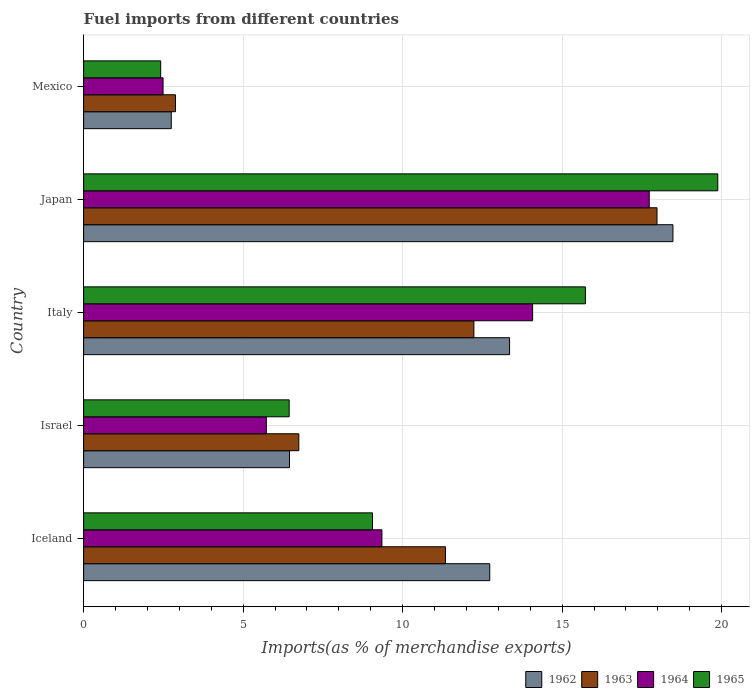How many different coloured bars are there?
Ensure brevity in your answer.  4. How many groups of bars are there?
Keep it short and to the point. 5. Are the number of bars per tick equal to the number of legend labels?
Ensure brevity in your answer.  Yes. What is the label of the 2nd group of bars from the top?
Offer a very short reply. Japan. What is the percentage of imports to different countries in 1962 in Iceland?
Your response must be concise. 12.73. Across all countries, what is the maximum percentage of imports to different countries in 1965?
Offer a terse response. 19.88. Across all countries, what is the minimum percentage of imports to different countries in 1964?
Ensure brevity in your answer.  2.49. What is the total percentage of imports to different countries in 1963 in the graph?
Provide a succinct answer. 51.18. What is the difference between the percentage of imports to different countries in 1962 in Japan and that in Mexico?
Provide a short and direct response. 15.73. What is the difference between the percentage of imports to different countries in 1964 in Japan and the percentage of imports to different countries in 1965 in Mexico?
Make the answer very short. 15.32. What is the average percentage of imports to different countries in 1962 per country?
Ensure brevity in your answer.  10.75. What is the difference between the percentage of imports to different countries in 1964 and percentage of imports to different countries in 1965 in Japan?
Your answer should be compact. -2.15. What is the ratio of the percentage of imports to different countries in 1965 in Italy to that in Mexico?
Give a very brief answer. 6.51. Is the percentage of imports to different countries in 1963 in Israel less than that in Italy?
Make the answer very short. Yes. Is the difference between the percentage of imports to different countries in 1964 in Iceland and Israel greater than the difference between the percentage of imports to different countries in 1965 in Iceland and Israel?
Offer a very short reply. Yes. What is the difference between the highest and the second highest percentage of imports to different countries in 1963?
Make the answer very short. 5.74. What is the difference between the highest and the lowest percentage of imports to different countries in 1962?
Offer a terse response. 15.73. In how many countries, is the percentage of imports to different countries in 1963 greater than the average percentage of imports to different countries in 1963 taken over all countries?
Your response must be concise. 3. Is the sum of the percentage of imports to different countries in 1962 in Israel and Japan greater than the maximum percentage of imports to different countries in 1963 across all countries?
Your response must be concise. Yes. Is it the case that in every country, the sum of the percentage of imports to different countries in 1963 and percentage of imports to different countries in 1964 is greater than the sum of percentage of imports to different countries in 1962 and percentage of imports to different countries in 1965?
Make the answer very short. No. What does the 3rd bar from the bottom in Iceland represents?
Ensure brevity in your answer.  1964. Is it the case that in every country, the sum of the percentage of imports to different countries in 1963 and percentage of imports to different countries in 1965 is greater than the percentage of imports to different countries in 1964?
Your response must be concise. Yes. How many bars are there?
Provide a short and direct response. 20. How many countries are there in the graph?
Offer a terse response. 5. Does the graph contain grids?
Offer a terse response. Yes. Where does the legend appear in the graph?
Give a very brief answer. Bottom right. What is the title of the graph?
Offer a terse response. Fuel imports from different countries. Does "1987" appear as one of the legend labels in the graph?
Provide a succinct answer. No. What is the label or title of the X-axis?
Offer a very short reply. Imports(as % of merchandise exports). What is the label or title of the Y-axis?
Your answer should be compact. Country. What is the Imports(as % of merchandise exports) of 1962 in Iceland?
Make the answer very short. 12.73. What is the Imports(as % of merchandise exports) of 1963 in Iceland?
Make the answer very short. 11.35. What is the Imports(as % of merchandise exports) of 1964 in Iceland?
Offer a terse response. 9.35. What is the Imports(as % of merchandise exports) in 1965 in Iceland?
Your answer should be very brief. 9.06. What is the Imports(as % of merchandise exports) in 1962 in Israel?
Give a very brief answer. 6.45. What is the Imports(as % of merchandise exports) in 1963 in Israel?
Your answer should be very brief. 6.75. What is the Imports(as % of merchandise exports) of 1964 in Israel?
Keep it short and to the point. 5.73. What is the Imports(as % of merchandise exports) of 1965 in Israel?
Offer a very short reply. 6.44. What is the Imports(as % of merchandise exports) in 1962 in Italy?
Give a very brief answer. 13.35. What is the Imports(as % of merchandise exports) in 1963 in Italy?
Your response must be concise. 12.23. What is the Imports(as % of merchandise exports) in 1964 in Italy?
Keep it short and to the point. 14.07. What is the Imports(as % of merchandise exports) of 1965 in Italy?
Your answer should be very brief. 15.73. What is the Imports(as % of merchandise exports) in 1962 in Japan?
Your answer should be very brief. 18.47. What is the Imports(as % of merchandise exports) in 1963 in Japan?
Offer a terse response. 17.97. What is the Imports(as % of merchandise exports) of 1964 in Japan?
Offer a terse response. 17.73. What is the Imports(as % of merchandise exports) in 1965 in Japan?
Make the answer very short. 19.88. What is the Imports(as % of merchandise exports) of 1962 in Mexico?
Keep it short and to the point. 2.75. What is the Imports(as % of merchandise exports) in 1963 in Mexico?
Keep it short and to the point. 2.88. What is the Imports(as % of merchandise exports) of 1964 in Mexico?
Your answer should be compact. 2.49. What is the Imports(as % of merchandise exports) of 1965 in Mexico?
Provide a short and direct response. 2.42. Across all countries, what is the maximum Imports(as % of merchandise exports) of 1962?
Ensure brevity in your answer.  18.47. Across all countries, what is the maximum Imports(as % of merchandise exports) of 1963?
Your answer should be very brief. 17.97. Across all countries, what is the maximum Imports(as % of merchandise exports) of 1964?
Make the answer very short. 17.73. Across all countries, what is the maximum Imports(as % of merchandise exports) in 1965?
Make the answer very short. 19.88. Across all countries, what is the minimum Imports(as % of merchandise exports) of 1962?
Provide a short and direct response. 2.75. Across all countries, what is the minimum Imports(as % of merchandise exports) of 1963?
Your answer should be very brief. 2.88. Across all countries, what is the minimum Imports(as % of merchandise exports) of 1964?
Provide a short and direct response. 2.49. Across all countries, what is the minimum Imports(as % of merchandise exports) in 1965?
Your answer should be very brief. 2.42. What is the total Imports(as % of merchandise exports) of 1962 in the graph?
Your answer should be very brief. 53.76. What is the total Imports(as % of merchandise exports) in 1963 in the graph?
Keep it short and to the point. 51.18. What is the total Imports(as % of merchandise exports) of 1964 in the graph?
Offer a terse response. 49.38. What is the total Imports(as % of merchandise exports) in 1965 in the graph?
Offer a very short reply. 53.53. What is the difference between the Imports(as % of merchandise exports) in 1962 in Iceland and that in Israel?
Offer a very short reply. 6.28. What is the difference between the Imports(as % of merchandise exports) in 1963 in Iceland and that in Israel?
Your response must be concise. 4.6. What is the difference between the Imports(as % of merchandise exports) of 1964 in Iceland and that in Israel?
Offer a very short reply. 3.62. What is the difference between the Imports(as % of merchandise exports) of 1965 in Iceland and that in Israel?
Your response must be concise. 2.61. What is the difference between the Imports(as % of merchandise exports) of 1962 in Iceland and that in Italy?
Ensure brevity in your answer.  -0.62. What is the difference between the Imports(as % of merchandise exports) of 1963 in Iceland and that in Italy?
Offer a terse response. -0.89. What is the difference between the Imports(as % of merchandise exports) in 1964 in Iceland and that in Italy?
Offer a terse response. -4.72. What is the difference between the Imports(as % of merchandise exports) in 1965 in Iceland and that in Italy?
Provide a succinct answer. -6.67. What is the difference between the Imports(as % of merchandise exports) of 1962 in Iceland and that in Japan?
Your response must be concise. -5.74. What is the difference between the Imports(as % of merchandise exports) in 1963 in Iceland and that in Japan?
Keep it short and to the point. -6.63. What is the difference between the Imports(as % of merchandise exports) in 1964 in Iceland and that in Japan?
Offer a very short reply. -8.38. What is the difference between the Imports(as % of merchandise exports) of 1965 in Iceland and that in Japan?
Offer a very short reply. -10.82. What is the difference between the Imports(as % of merchandise exports) of 1962 in Iceland and that in Mexico?
Provide a succinct answer. 9.98. What is the difference between the Imports(as % of merchandise exports) in 1963 in Iceland and that in Mexico?
Provide a succinct answer. 8.47. What is the difference between the Imports(as % of merchandise exports) of 1964 in Iceland and that in Mexico?
Give a very brief answer. 6.86. What is the difference between the Imports(as % of merchandise exports) in 1965 in Iceland and that in Mexico?
Offer a terse response. 6.64. What is the difference between the Imports(as % of merchandise exports) of 1962 in Israel and that in Italy?
Your answer should be very brief. -6.9. What is the difference between the Imports(as % of merchandise exports) of 1963 in Israel and that in Italy?
Offer a terse response. -5.49. What is the difference between the Imports(as % of merchandise exports) of 1964 in Israel and that in Italy?
Provide a short and direct response. -8.35. What is the difference between the Imports(as % of merchandise exports) of 1965 in Israel and that in Italy?
Your response must be concise. -9.29. What is the difference between the Imports(as % of merchandise exports) in 1962 in Israel and that in Japan?
Keep it short and to the point. -12.02. What is the difference between the Imports(as % of merchandise exports) of 1963 in Israel and that in Japan?
Ensure brevity in your answer.  -11.23. What is the difference between the Imports(as % of merchandise exports) of 1964 in Israel and that in Japan?
Offer a terse response. -12. What is the difference between the Imports(as % of merchandise exports) of 1965 in Israel and that in Japan?
Give a very brief answer. -13.44. What is the difference between the Imports(as % of merchandise exports) of 1962 in Israel and that in Mexico?
Make the answer very short. 3.71. What is the difference between the Imports(as % of merchandise exports) in 1963 in Israel and that in Mexico?
Your response must be concise. 3.87. What is the difference between the Imports(as % of merchandise exports) in 1964 in Israel and that in Mexico?
Provide a short and direct response. 3.24. What is the difference between the Imports(as % of merchandise exports) of 1965 in Israel and that in Mexico?
Keep it short and to the point. 4.03. What is the difference between the Imports(as % of merchandise exports) of 1962 in Italy and that in Japan?
Your answer should be very brief. -5.12. What is the difference between the Imports(as % of merchandise exports) of 1963 in Italy and that in Japan?
Provide a succinct answer. -5.74. What is the difference between the Imports(as % of merchandise exports) of 1964 in Italy and that in Japan?
Make the answer very short. -3.66. What is the difference between the Imports(as % of merchandise exports) in 1965 in Italy and that in Japan?
Keep it short and to the point. -4.15. What is the difference between the Imports(as % of merchandise exports) in 1962 in Italy and that in Mexico?
Give a very brief answer. 10.61. What is the difference between the Imports(as % of merchandise exports) of 1963 in Italy and that in Mexico?
Make the answer very short. 9.36. What is the difference between the Imports(as % of merchandise exports) in 1964 in Italy and that in Mexico?
Ensure brevity in your answer.  11.58. What is the difference between the Imports(as % of merchandise exports) of 1965 in Italy and that in Mexico?
Keep it short and to the point. 13.31. What is the difference between the Imports(as % of merchandise exports) of 1962 in Japan and that in Mexico?
Your answer should be compact. 15.73. What is the difference between the Imports(as % of merchandise exports) of 1963 in Japan and that in Mexico?
Offer a terse response. 15.1. What is the difference between the Imports(as % of merchandise exports) in 1964 in Japan and that in Mexico?
Offer a terse response. 15.24. What is the difference between the Imports(as % of merchandise exports) of 1965 in Japan and that in Mexico?
Offer a terse response. 17.46. What is the difference between the Imports(as % of merchandise exports) in 1962 in Iceland and the Imports(as % of merchandise exports) in 1963 in Israel?
Provide a short and direct response. 5.99. What is the difference between the Imports(as % of merchandise exports) of 1962 in Iceland and the Imports(as % of merchandise exports) of 1964 in Israel?
Ensure brevity in your answer.  7. What is the difference between the Imports(as % of merchandise exports) of 1962 in Iceland and the Imports(as % of merchandise exports) of 1965 in Israel?
Offer a very short reply. 6.29. What is the difference between the Imports(as % of merchandise exports) of 1963 in Iceland and the Imports(as % of merchandise exports) of 1964 in Israel?
Keep it short and to the point. 5.62. What is the difference between the Imports(as % of merchandise exports) of 1963 in Iceland and the Imports(as % of merchandise exports) of 1965 in Israel?
Offer a terse response. 4.9. What is the difference between the Imports(as % of merchandise exports) of 1964 in Iceland and the Imports(as % of merchandise exports) of 1965 in Israel?
Give a very brief answer. 2.91. What is the difference between the Imports(as % of merchandise exports) of 1962 in Iceland and the Imports(as % of merchandise exports) of 1963 in Italy?
Your answer should be very brief. 0.5. What is the difference between the Imports(as % of merchandise exports) of 1962 in Iceland and the Imports(as % of merchandise exports) of 1964 in Italy?
Provide a succinct answer. -1.34. What is the difference between the Imports(as % of merchandise exports) of 1962 in Iceland and the Imports(as % of merchandise exports) of 1965 in Italy?
Your answer should be compact. -3. What is the difference between the Imports(as % of merchandise exports) in 1963 in Iceland and the Imports(as % of merchandise exports) in 1964 in Italy?
Offer a very short reply. -2.73. What is the difference between the Imports(as % of merchandise exports) in 1963 in Iceland and the Imports(as % of merchandise exports) in 1965 in Italy?
Offer a very short reply. -4.38. What is the difference between the Imports(as % of merchandise exports) in 1964 in Iceland and the Imports(as % of merchandise exports) in 1965 in Italy?
Offer a terse response. -6.38. What is the difference between the Imports(as % of merchandise exports) in 1962 in Iceland and the Imports(as % of merchandise exports) in 1963 in Japan?
Provide a short and direct response. -5.24. What is the difference between the Imports(as % of merchandise exports) in 1962 in Iceland and the Imports(as % of merchandise exports) in 1964 in Japan?
Offer a very short reply. -5. What is the difference between the Imports(as % of merchandise exports) of 1962 in Iceland and the Imports(as % of merchandise exports) of 1965 in Japan?
Your response must be concise. -7.15. What is the difference between the Imports(as % of merchandise exports) in 1963 in Iceland and the Imports(as % of merchandise exports) in 1964 in Japan?
Keep it short and to the point. -6.39. What is the difference between the Imports(as % of merchandise exports) of 1963 in Iceland and the Imports(as % of merchandise exports) of 1965 in Japan?
Your answer should be compact. -8.53. What is the difference between the Imports(as % of merchandise exports) of 1964 in Iceland and the Imports(as % of merchandise exports) of 1965 in Japan?
Offer a terse response. -10.53. What is the difference between the Imports(as % of merchandise exports) in 1962 in Iceland and the Imports(as % of merchandise exports) in 1963 in Mexico?
Keep it short and to the point. 9.85. What is the difference between the Imports(as % of merchandise exports) of 1962 in Iceland and the Imports(as % of merchandise exports) of 1964 in Mexico?
Keep it short and to the point. 10.24. What is the difference between the Imports(as % of merchandise exports) of 1962 in Iceland and the Imports(as % of merchandise exports) of 1965 in Mexico?
Ensure brevity in your answer.  10.32. What is the difference between the Imports(as % of merchandise exports) of 1963 in Iceland and the Imports(as % of merchandise exports) of 1964 in Mexico?
Keep it short and to the point. 8.85. What is the difference between the Imports(as % of merchandise exports) of 1963 in Iceland and the Imports(as % of merchandise exports) of 1965 in Mexico?
Offer a very short reply. 8.93. What is the difference between the Imports(as % of merchandise exports) in 1964 in Iceland and the Imports(as % of merchandise exports) in 1965 in Mexico?
Ensure brevity in your answer.  6.94. What is the difference between the Imports(as % of merchandise exports) in 1962 in Israel and the Imports(as % of merchandise exports) in 1963 in Italy?
Make the answer very short. -5.78. What is the difference between the Imports(as % of merchandise exports) in 1962 in Israel and the Imports(as % of merchandise exports) in 1964 in Italy?
Give a very brief answer. -7.62. What is the difference between the Imports(as % of merchandise exports) in 1962 in Israel and the Imports(as % of merchandise exports) in 1965 in Italy?
Keep it short and to the point. -9.28. What is the difference between the Imports(as % of merchandise exports) of 1963 in Israel and the Imports(as % of merchandise exports) of 1964 in Italy?
Your response must be concise. -7.33. What is the difference between the Imports(as % of merchandise exports) of 1963 in Israel and the Imports(as % of merchandise exports) of 1965 in Italy?
Provide a succinct answer. -8.98. What is the difference between the Imports(as % of merchandise exports) of 1964 in Israel and the Imports(as % of merchandise exports) of 1965 in Italy?
Make the answer very short. -10. What is the difference between the Imports(as % of merchandise exports) in 1962 in Israel and the Imports(as % of merchandise exports) in 1963 in Japan?
Offer a terse response. -11.52. What is the difference between the Imports(as % of merchandise exports) in 1962 in Israel and the Imports(as % of merchandise exports) in 1964 in Japan?
Provide a succinct answer. -11.28. What is the difference between the Imports(as % of merchandise exports) of 1962 in Israel and the Imports(as % of merchandise exports) of 1965 in Japan?
Ensure brevity in your answer.  -13.43. What is the difference between the Imports(as % of merchandise exports) of 1963 in Israel and the Imports(as % of merchandise exports) of 1964 in Japan?
Give a very brief answer. -10.99. What is the difference between the Imports(as % of merchandise exports) of 1963 in Israel and the Imports(as % of merchandise exports) of 1965 in Japan?
Provide a short and direct response. -13.13. What is the difference between the Imports(as % of merchandise exports) of 1964 in Israel and the Imports(as % of merchandise exports) of 1965 in Japan?
Offer a terse response. -14.15. What is the difference between the Imports(as % of merchandise exports) in 1962 in Israel and the Imports(as % of merchandise exports) in 1963 in Mexico?
Your answer should be compact. 3.58. What is the difference between the Imports(as % of merchandise exports) in 1962 in Israel and the Imports(as % of merchandise exports) in 1964 in Mexico?
Make the answer very short. 3.96. What is the difference between the Imports(as % of merchandise exports) in 1962 in Israel and the Imports(as % of merchandise exports) in 1965 in Mexico?
Offer a terse response. 4.04. What is the difference between the Imports(as % of merchandise exports) of 1963 in Israel and the Imports(as % of merchandise exports) of 1964 in Mexico?
Ensure brevity in your answer.  4.26. What is the difference between the Imports(as % of merchandise exports) of 1963 in Israel and the Imports(as % of merchandise exports) of 1965 in Mexico?
Your answer should be very brief. 4.33. What is the difference between the Imports(as % of merchandise exports) of 1964 in Israel and the Imports(as % of merchandise exports) of 1965 in Mexico?
Offer a terse response. 3.31. What is the difference between the Imports(as % of merchandise exports) in 1962 in Italy and the Imports(as % of merchandise exports) in 1963 in Japan?
Keep it short and to the point. -4.62. What is the difference between the Imports(as % of merchandise exports) in 1962 in Italy and the Imports(as % of merchandise exports) in 1964 in Japan?
Your response must be concise. -4.38. What is the difference between the Imports(as % of merchandise exports) in 1962 in Italy and the Imports(as % of merchandise exports) in 1965 in Japan?
Give a very brief answer. -6.53. What is the difference between the Imports(as % of merchandise exports) in 1963 in Italy and the Imports(as % of merchandise exports) in 1964 in Japan?
Your answer should be compact. -5.5. What is the difference between the Imports(as % of merchandise exports) in 1963 in Italy and the Imports(as % of merchandise exports) in 1965 in Japan?
Provide a short and direct response. -7.65. What is the difference between the Imports(as % of merchandise exports) in 1964 in Italy and the Imports(as % of merchandise exports) in 1965 in Japan?
Your response must be concise. -5.8. What is the difference between the Imports(as % of merchandise exports) of 1962 in Italy and the Imports(as % of merchandise exports) of 1963 in Mexico?
Your answer should be compact. 10.47. What is the difference between the Imports(as % of merchandise exports) in 1962 in Italy and the Imports(as % of merchandise exports) in 1964 in Mexico?
Your answer should be compact. 10.86. What is the difference between the Imports(as % of merchandise exports) in 1962 in Italy and the Imports(as % of merchandise exports) in 1965 in Mexico?
Your answer should be very brief. 10.94. What is the difference between the Imports(as % of merchandise exports) in 1963 in Italy and the Imports(as % of merchandise exports) in 1964 in Mexico?
Give a very brief answer. 9.74. What is the difference between the Imports(as % of merchandise exports) of 1963 in Italy and the Imports(as % of merchandise exports) of 1965 in Mexico?
Give a very brief answer. 9.82. What is the difference between the Imports(as % of merchandise exports) in 1964 in Italy and the Imports(as % of merchandise exports) in 1965 in Mexico?
Your response must be concise. 11.66. What is the difference between the Imports(as % of merchandise exports) in 1962 in Japan and the Imports(as % of merchandise exports) in 1963 in Mexico?
Give a very brief answer. 15.6. What is the difference between the Imports(as % of merchandise exports) of 1962 in Japan and the Imports(as % of merchandise exports) of 1964 in Mexico?
Give a very brief answer. 15.98. What is the difference between the Imports(as % of merchandise exports) of 1962 in Japan and the Imports(as % of merchandise exports) of 1965 in Mexico?
Ensure brevity in your answer.  16.06. What is the difference between the Imports(as % of merchandise exports) in 1963 in Japan and the Imports(as % of merchandise exports) in 1964 in Mexico?
Your answer should be very brief. 15.48. What is the difference between the Imports(as % of merchandise exports) of 1963 in Japan and the Imports(as % of merchandise exports) of 1965 in Mexico?
Offer a very short reply. 15.56. What is the difference between the Imports(as % of merchandise exports) of 1964 in Japan and the Imports(as % of merchandise exports) of 1965 in Mexico?
Keep it short and to the point. 15.32. What is the average Imports(as % of merchandise exports) of 1962 per country?
Your response must be concise. 10.75. What is the average Imports(as % of merchandise exports) of 1963 per country?
Provide a short and direct response. 10.24. What is the average Imports(as % of merchandise exports) of 1964 per country?
Provide a succinct answer. 9.88. What is the average Imports(as % of merchandise exports) in 1965 per country?
Your answer should be compact. 10.71. What is the difference between the Imports(as % of merchandise exports) in 1962 and Imports(as % of merchandise exports) in 1963 in Iceland?
Keep it short and to the point. 1.39. What is the difference between the Imports(as % of merchandise exports) of 1962 and Imports(as % of merchandise exports) of 1964 in Iceland?
Ensure brevity in your answer.  3.38. What is the difference between the Imports(as % of merchandise exports) of 1962 and Imports(as % of merchandise exports) of 1965 in Iceland?
Offer a very short reply. 3.67. What is the difference between the Imports(as % of merchandise exports) in 1963 and Imports(as % of merchandise exports) in 1964 in Iceland?
Ensure brevity in your answer.  1.99. What is the difference between the Imports(as % of merchandise exports) in 1963 and Imports(as % of merchandise exports) in 1965 in Iceland?
Your answer should be very brief. 2.29. What is the difference between the Imports(as % of merchandise exports) of 1964 and Imports(as % of merchandise exports) of 1965 in Iceland?
Keep it short and to the point. 0.29. What is the difference between the Imports(as % of merchandise exports) in 1962 and Imports(as % of merchandise exports) in 1963 in Israel?
Your response must be concise. -0.29. What is the difference between the Imports(as % of merchandise exports) of 1962 and Imports(as % of merchandise exports) of 1964 in Israel?
Provide a succinct answer. 0.73. What is the difference between the Imports(as % of merchandise exports) of 1962 and Imports(as % of merchandise exports) of 1965 in Israel?
Your answer should be very brief. 0.01. What is the difference between the Imports(as % of merchandise exports) of 1963 and Imports(as % of merchandise exports) of 1964 in Israel?
Your answer should be compact. 1.02. What is the difference between the Imports(as % of merchandise exports) in 1963 and Imports(as % of merchandise exports) in 1965 in Israel?
Offer a terse response. 0.3. What is the difference between the Imports(as % of merchandise exports) in 1964 and Imports(as % of merchandise exports) in 1965 in Israel?
Your response must be concise. -0.72. What is the difference between the Imports(as % of merchandise exports) in 1962 and Imports(as % of merchandise exports) in 1963 in Italy?
Keep it short and to the point. 1.12. What is the difference between the Imports(as % of merchandise exports) in 1962 and Imports(as % of merchandise exports) in 1964 in Italy?
Your answer should be compact. -0.72. What is the difference between the Imports(as % of merchandise exports) of 1962 and Imports(as % of merchandise exports) of 1965 in Italy?
Provide a succinct answer. -2.38. What is the difference between the Imports(as % of merchandise exports) of 1963 and Imports(as % of merchandise exports) of 1964 in Italy?
Your answer should be very brief. -1.84. What is the difference between the Imports(as % of merchandise exports) of 1963 and Imports(as % of merchandise exports) of 1965 in Italy?
Offer a terse response. -3.5. What is the difference between the Imports(as % of merchandise exports) of 1964 and Imports(as % of merchandise exports) of 1965 in Italy?
Keep it short and to the point. -1.65. What is the difference between the Imports(as % of merchandise exports) of 1962 and Imports(as % of merchandise exports) of 1964 in Japan?
Ensure brevity in your answer.  0.74. What is the difference between the Imports(as % of merchandise exports) in 1962 and Imports(as % of merchandise exports) in 1965 in Japan?
Provide a short and direct response. -1.41. What is the difference between the Imports(as % of merchandise exports) of 1963 and Imports(as % of merchandise exports) of 1964 in Japan?
Provide a short and direct response. 0.24. What is the difference between the Imports(as % of merchandise exports) in 1963 and Imports(as % of merchandise exports) in 1965 in Japan?
Offer a terse response. -1.91. What is the difference between the Imports(as % of merchandise exports) of 1964 and Imports(as % of merchandise exports) of 1965 in Japan?
Your answer should be compact. -2.15. What is the difference between the Imports(as % of merchandise exports) in 1962 and Imports(as % of merchandise exports) in 1963 in Mexico?
Provide a succinct answer. -0.13. What is the difference between the Imports(as % of merchandise exports) in 1962 and Imports(as % of merchandise exports) in 1964 in Mexico?
Offer a very short reply. 0.26. What is the difference between the Imports(as % of merchandise exports) of 1962 and Imports(as % of merchandise exports) of 1965 in Mexico?
Your response must be concise. 0.33. What is the difference between the Imports(as % of merchandise exports) in 1963 and Imports(as % of merchandise exports) in 1964 in Mexico?
Give a very brief answer. 0.39. What is the difference between the Imports(as % of merchandise exports) in 1963 and Imports(as % of merchandise exports) in 1965 in Mexico?
Your answer should be compact. 0.46. What is the difference between the Imports(as % of merchandise exports) of 1964 and Imports(as % of merchandise exports) of 1965 in Mexico?
Offer a very short reply. 0.07. What is the ratio of the Imports(as % of merchandise exports) in 1962 in Iceland to that in Israel?
Make the answer very short. 1.97. What is the ratio of the Imports(as % of merchandise exports) in 1963 in Iceland to that in Israel?
Offer a terse response. 1.68. What is the ratio of the Imports(as % of merchandise exports) of 1964 in Iceland to that in Israel?
Your response must be concise. 1.63. What is the ratio of the Imports(as % of merchandise exports) of 1965 in Iceland to that in Israel?
Provide a succinct answer. 1.41. What is the ratio of the Imports(as % of merchandise exports) in 1962 in Iceland to that in Italy?
Make the answer very short. 0.95. What is the ratio of the Imports(as % of merchandise exports) in 1963 in Iceland to that in Italy?
Ensure brevity in your answer.  0.93. What is the ratio of the Imports(as % of merchandise exports) of 1964 in Iceland to that in Italy?
Make the answer very short. 0.66. What is the ratio of the Imports(as % of merchandise exports) in 1965 in Iceland to that in Italy?
Your answer should be very brief. 0.58. What is the ratio of the Imports(as % of merchandise exports) of 1962 in Iceland to that in Japan?
Provide a succinct answer. 0.69. What is the ratio of the Imports(as % of merchandise exports) in 1963 in Iceland to that in Japan?
Ensure brevity in your answer.  0.63. What is the ratio of the Imports(as % of merchandise exports) in 1964 in Iceland to that in Japan?
Ensure brevity in your answer.  0.53. What is the ratio of the Imports(as % of merchandise exports) in 1965 in Iceland to that in Japan?
Provide a short and direct response. 0.46. What is the ratio of the Imports(as % of merchandise exports) in 1962 in Iceland to that in Mexico?
Provide a succinct answer. 4.63. What is the ratio of the Imports(as % of merchandise exports) of 1963 in Iceland to that in Mexico?
Provide a short and direct response. 3.94. What is the ratio of the Imports(as % of merchandise exports) in 1964 in Iceland to that in Mexico?
Offer a very short reply. 3.76. What is the ratio of the Imports(as % of merchandise exports) in 1965 in Iceland to that in Mexico?
Make the answer very short. 3.75. What is the ratio of the Imports(as % of merchandise exports) in 1962 in Israel to that in Italy?
Keep it short and to the point. 0.48. What is the ratio of the Imports(as % of merchandise exports) in 1963 in Israel to that in Italy?
Your answer should be compact. 0.55. What is the ratio of the Imports(as % of merchandise exports) of 1964 in Israel to that in Italy?
Your answer should be compact. 0.41. What is the ratio of the Imports(as % of merchandise exports) of 1965 in Israel to that in Italy?
Provide a short and direct response. 0.41. What is the ratio of the Imports(as % of merchandise exports) in 1962 in Israel to that in Japan?
Your response must be concise. 0.35. What is the ratio of the Imports(as % of merchandise exports) in 1963 in Israel to that in Japan?
Make the answer very short. 0.38. What is the ratio of the Imports(as % of merchandise exports) of 1964 in Israel to that in Japan?
Ensure brevity in your answer.  0.32. What is the ratio of the Imports(as % of merchandise exports) of 1965 in Israel to that in Japan?
Offer a terse response. 0.32. What is the ratio of the Imports(as % of merchandise exports) in 1962 in Israel to that in Mexico?
Provide a succinct answer. 2.35. What is the ratio of the Imports(as % of merchandise exports) in 1963 in Israel to that in Mexico?
Your answer should be compact. 2.34. What is the ratio of the Imports(as % of merchandise exports) in 1964 in Israel to that in Mexico?
Your answer should be very brief. 2.3. What is the ratio of the Imports(as % of merchandise exports) in 1965 in Israel to that in Mexico?
Your response must be concise. 2.67. What is the ratio of the Imports(as % of merchandise exports) in 1962 in Italy to that in Japan?
Ensure brevity in your answer.  0.72. What is the ratio of the Imports(as % of merchandise exports) of 1963 in Italy to that in Japan?
Your answer should be very brief. 0.68. What is the ratio of the Imports(as % of merchandise exports) of 1964 in Italy to that in Japan?
Make the answer very short. 0.79. What is the ratio of the Imports(as % of merchandise exports) of 1965 in Italy to that in Japan?
Give a very brief answer. 0.79. What is the ratio of the Imports(as % of merchandise exports) of 1962 in Italy to that in Mexico?
Your response must be concise. 4.86. What is the ratio of the Imports(as % of merchandise exports) in 1963 in Italy to that in Mexico?
Make the answer very short. 4.25. What is the ratio of the Imports(as % of merchandise exports) in 1964 in Italy to that in Mexico?
Give a very brief answer. 5.65. What is the ratio of the Imports(as % of merchandise exports) in 1965 in Italy to that in Mexico?
Keep it short and to the point. 6.51. What is the ratio of the Imports(as % of merchandise exports) in 1962 in Japan to that in Mexico?
Ensure brevity in your answer.  6.72. What is the ratio of the Imports(as % of merchandise exports) in 1963 in Japan to that in Mexico?
Your response must be concise. 6.24. What is the ratio of the Imports(as % of merchandise exports) in 1964 in Japan to that in Mexico?
Offer a terse response. 7.12. What is the ratio of the Imports(as % of merchandise exports) in 1965 in Japan to that in Mexico?
Give a very brief answer. 8.23. What is the difference between the highest and the second highest Imports(as % of merchandise exports) in 1962?
Provide a short and direct response. 5.12. What is the difference between the highest and the second highest Imports(as % of merchandise exports) in 1963?
Give a very brief answer. 5.74. What is the difference between the highest and the second highest Imports(as % of merchandise exports) in 1964?
Your response must be concise. 3.66. What is the difference between the highest and the second highest Imports(as % of merchandise exports) in 1965?
Provide a succinct answer. 4.15. What is the difference between the highest and the lowest Imports(as % of merchandise exports) of 1962?
Ensure brevity in your answer.  15.73. What is the difference between the highest and the lowest Imports(as % of merchandise exports) in 1963?
Ensure brevity in your answer.  15.1. What is the difference between the highest and the lowest Imports(as % of merchandise exports) of 1964?
Your answer should be very brief. 15.24. What is the difference between the highest and the lowest Imports(as % of merchandise exports) of 1965?
Your response must be concise. 17.46. 